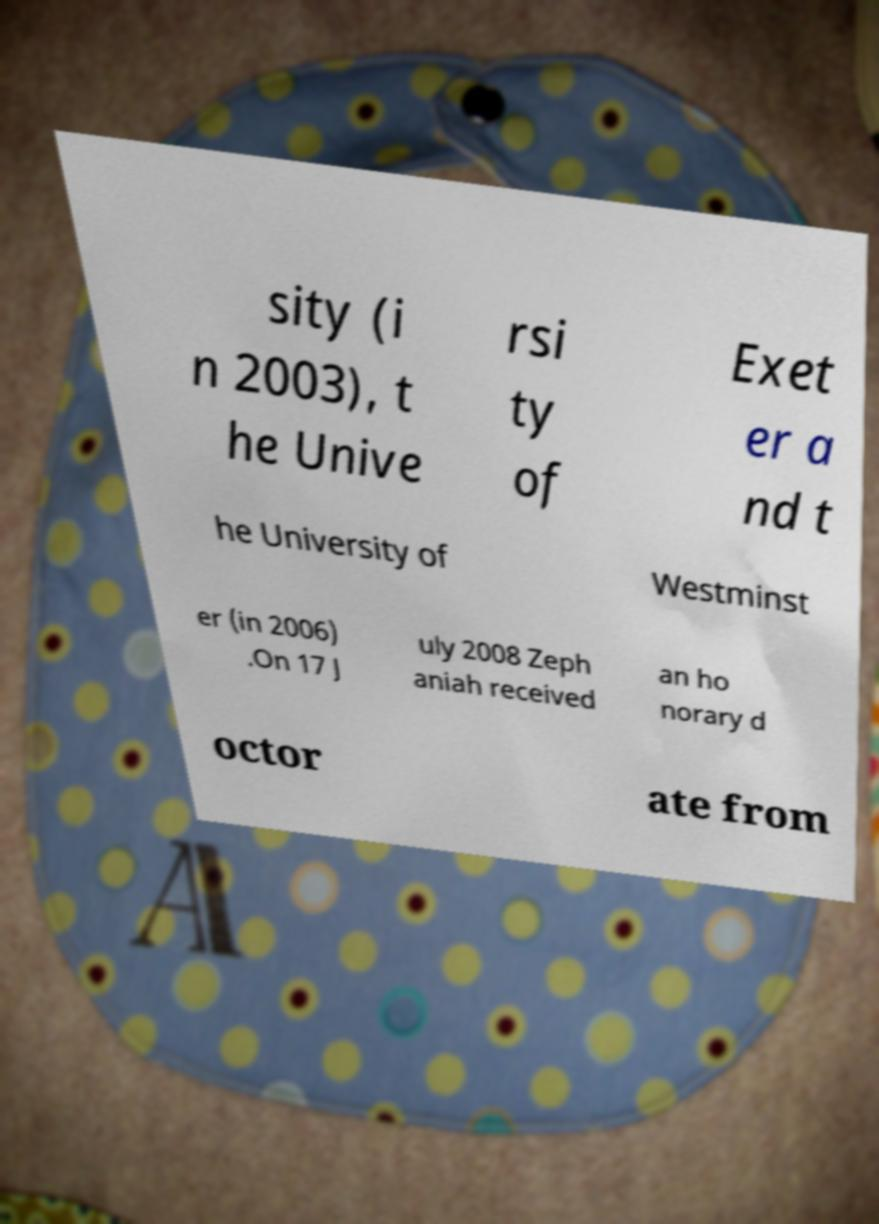There's text embedded in this image that I need extracted. Can you transcribe it verbatim? sity (i n 2003), t he Unive rsi ty of Exet er a nd t he University of Westminst er (in 2006) .On 17 J uly 2008 Zeph aniah received an ho norary d octor ate from 